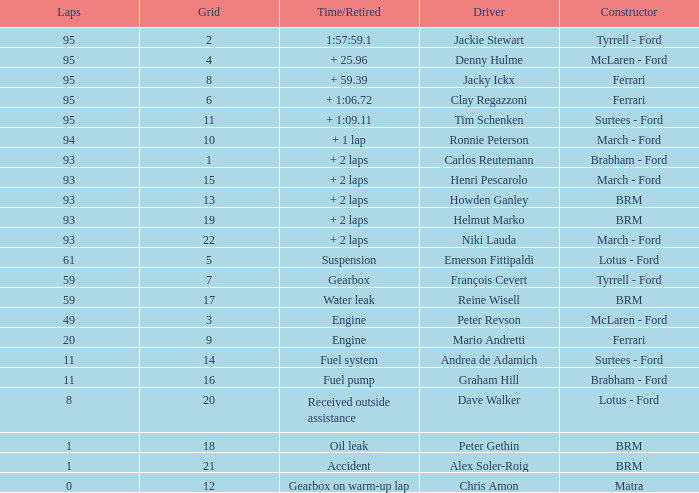What is the total number of grids for peter gethin? 18.0. 